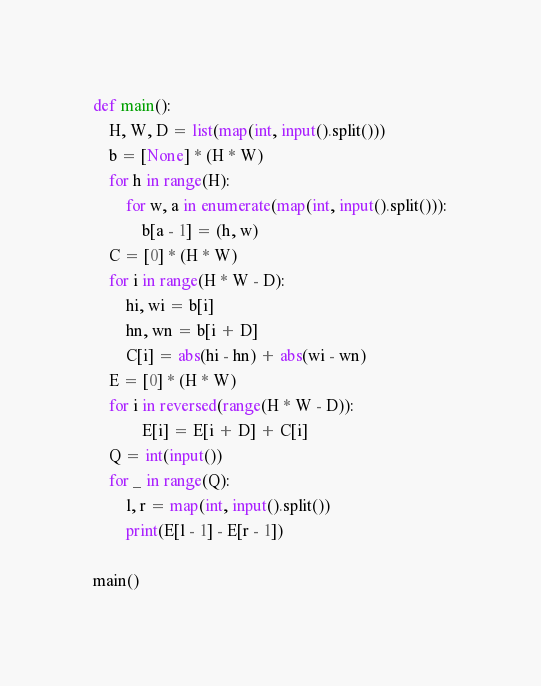<code> <loc_0><loc_0><loc_500><loc_500><_Python_>def main():
    H, W, D = list(map(int, input().split()))
    b = [None] * (H * W)
    for h in range(H):
        for w, a in enumerate(map(int, input().split())):
            b[a - 1] = (h, w)
    C = [0] * (H * W)
    for i in range(H * W - D):
        hi, wi = b[i]
        hn, wn = b[i + D]
        C[i] = abs(hi - hn) + abs(wi - wn)
    E = [0] * (H * W)
    for i in reversed(range(H * W - D)):
            E[i] = E[i + D] + C[i]
    Q = int(input())
    for _ in range(Q):
        l, r = map(int, input().split())
        print(E[l - 1] - E[r - 1])
        
main()
</code> 